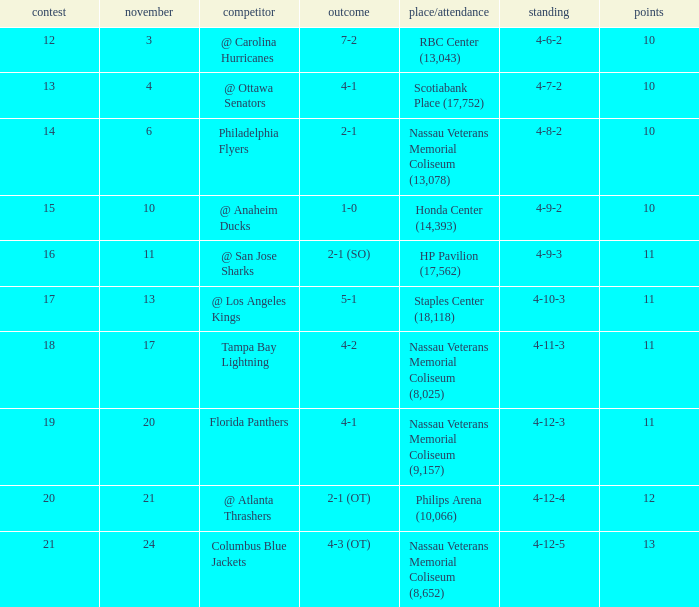On november 21, what games are scheduled? 20.0. 